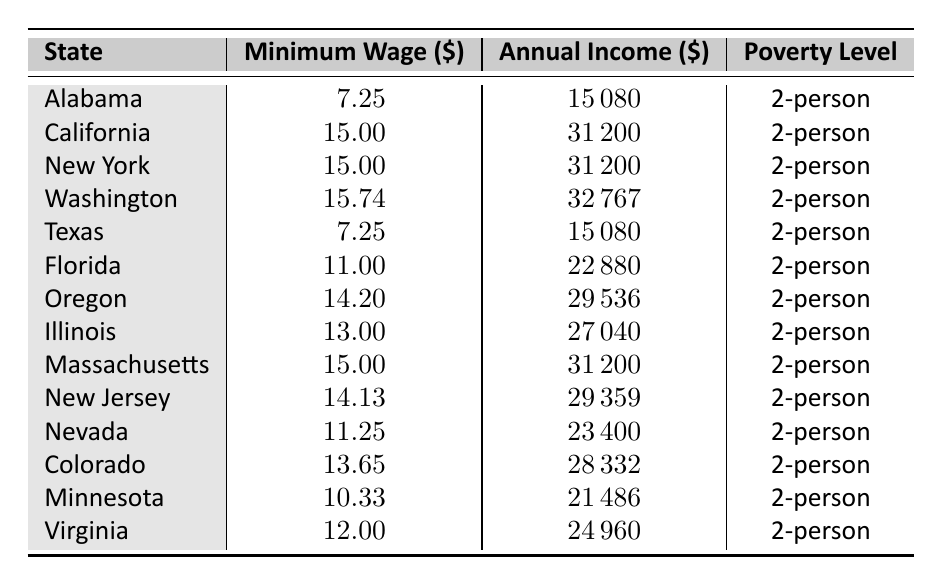What is the minimum wage in California? The table lists California's minimum wage directly under the "Minimum Wage" column. California's minimum wage is 15.00.
Answer: 15.00 Which state has the highest minimum wage? By comparing the "Minimum Wage" column, Washington has the highest minimum wage at 15.74.
Answer: Washington What is the annual income for a full-time worker earning the minimum wage in Texas? The "Annual Income" column indicates that a full-time worker earning Texas's minimum wage earns 15,080 annually.
Answer: 15080 Is the minimum wage in New York higher than that in Florida? The minimum wage in New York (15.00) is compared to Florida's minimum wage (11.00). Yes, New York's minimum wage is higher.
Answer: Yes What is the average minimum wage among the listed states? Add all minimum wages (7.25 + 15.00 + 15.00 + 15.74 + 7.25 + 11.00 + 14.20 + 13.00 + 15.00 + 14.13 + 11.25 + 13.65 + 10.33 + 12.00) = 10.86, and divide by 14 states gives an average of 12.36.
Answer: 12.36 Which states have a minimum wage below the national minimum wage of 7.25? Alabama and Texas have minimum wages of 7.25, which are equal to the national minimum wage, and no states have wages below it.
Answer: No states What is the difference in annual income between the states with the highest and lowest minimum wage? Washington's annual income (32,767) minus Alabama's (15,080) gives a difference of 17,687.
Answer: 17687 Are there more states with a minimum wage of 15.00 or more compared to those below 12.00? There are 5 states (California, New York, Washington, Massachusetts, Oregon) with a minimum wage of 15.00 or more; only 4 states (Alabama, Texas, Florida, Minnesota) have a minimum wage below 12.00. Thus, there are more states earning 15.00 or more.
Answer: 5 What proportion of states listed have a poverty level of 2-person incomes at or above the federal income level based on minimum wages? There are 14 states, and only 3 states have annual incomes below the minimum poverty level of 15,000. Thus, (14 - 3) / 14 = 11 / 14 ≈ 0.79 or 79% above the poverty level.
Answer: 79% 